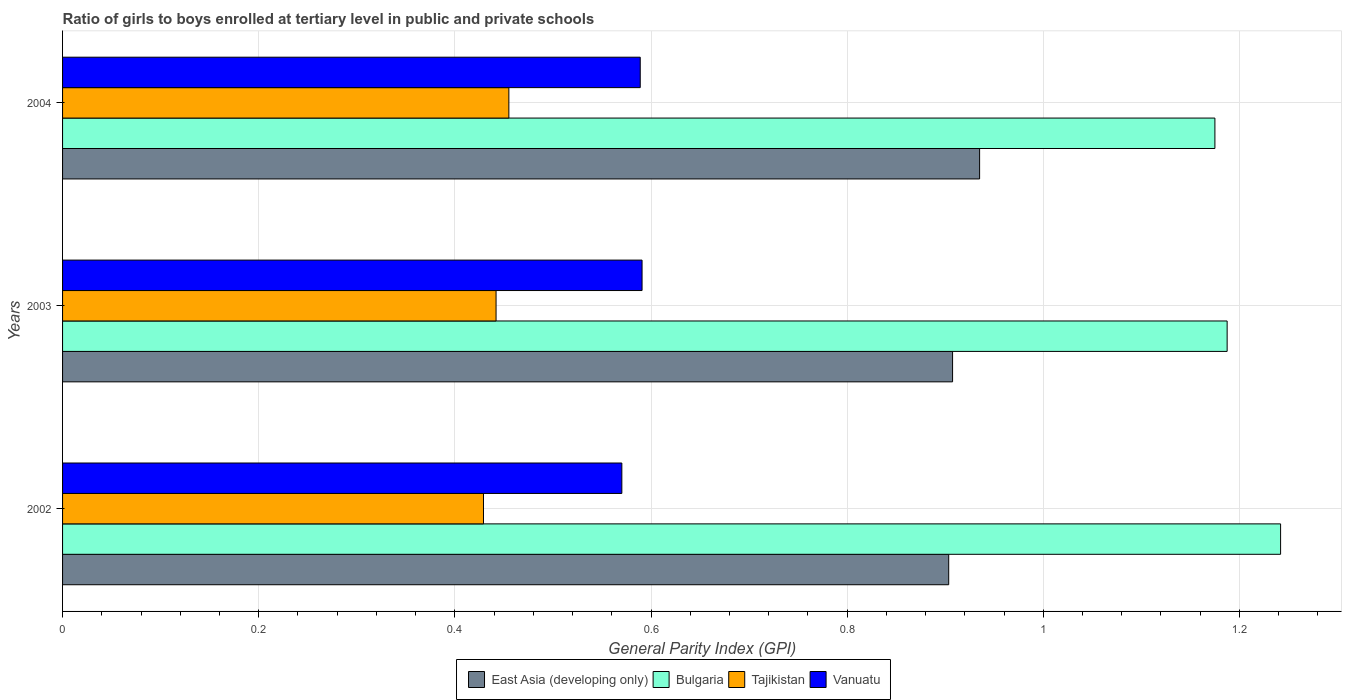How many bars are there on the 2nd tick from the top?
Keep it short and to the point. 4. In how many cases, is the number of bars for a given year not equal to the number of legend labels?
Give a very brief answer. 0. What is the general parity index in Bulgaria in 2002?
Your response must be concise. 1.24. Across all years, what is the maximum general parity index in Tajikistan?
Make the answer very short. 0.46. Across all years, what is the minimum general parity index in East Asia (developing only)?
Your answer should be very brief. 0.9. In which year was the general parity index in Vanuatu minimum?
Ensure brevity in your answer.  2002. What is the total general parity index in Bulgaria in the graph?
Provide a short and direct response. 3.6. What is the difference between the general parity index in Tajikistan in 2002 and that in 2003?
Give a very brief answer. -0.01. What is the difference between the general parity index in East Asia (developing only) in 2003 and the general parity index in Vanuatu in 2002?
Your response must be concise. 0.34. What is the average general parity index in Bulgaria per year?
Ensure brevity in your answer.  1.2. In the year 2003, what is the difference between the general parity index in Vanuatu and general parity index in Bulgaria?
Offer a very short reply. -0.6. In how many years, is the general parity index in Bulgaria greater than 1.08 ?
Offer a very short reply. 3. What is the ratio of the general parity index in Bulgaria in 2002 to that in 2004?
Your answer should be very brief. 1.06. Is the general parity index in Bulgaria in 2003 less than that in 2004?
Offer a terse response. No. What is the difference between the highest and the second highest general parity index in East Asia (developing only)?
Your response must be concise. 0.03. What is the difference between the highest and the lowest general parity index in Bulgaria?
Provide a succinct answer. 0.07. What does the 1st bar from the top in 2002 represents?
Offer a terse response. Vanuatu. What does the 1st bar from the bottom in 2003 represents?
Offer a very short reply. East Asia (developing only). Is it the case that in every year, the sum of the general parity index in Vanuatu and general parity index in Tajikistan is greater than the general parity index in Bulgaria?
Offer a very short reply. No. How many bars are there?
Make the answer very short. 12. Are all the bars in the graph horizontal?
Keep it short and to the point. Yes. Are the values on the major ticks of X-axis written in scientific E-notation?
Offer a very short reply. No. Does the graph contain any zero values?
Offer a very short reply. No. Does the graph contain grids?
Keep it short and to the point. Yes. Where does the legend appear in the graph?
Offer a terse response. Bottom center. How many legend labels are there?
Your response must be concise. 4. How are the legend labels stacked?
Offer a terse response. Horizontal. What is the title of the graph?
Your answer should be very brief. Ratio of girls to boys enrolled at tertiary level in public and private schools. What is the label or title of the X-axis?
Keep it short and to the point. General Parity Index (GPI). What is the General Parity Index (GPI) of East Asia (developing only) in 2002?
Your response must be concise. 0.9. What is the General Parity Index (GPI) of Bulgaria in 2002?
Give a very brief answer. 1.24. What is the General Parity Index (GPI) in Tajikistan in 2002?
Offer a very short reply. 0.43. What is the General Parity Index (GPI) of Vanuatu in 2002?
Your answer should be very brief. 0.57. What is the General Parity Index (GPI) in East Asia (developing only) in 2003?
Give a very brief answer. 0.91. What is the General Parity Index (GPI) in Bulgaria in 2003?
Offer a very short reply. 1.19. What is the General Parity Index (GPI) in Tajikistan in 2003?
Your answer should be very brief. 0.44. What is the General Parity Index (GPI) of Vanuatu in 2003?
Make the answer very short. 0.59. What is the General Parity Index (GPI) in East Asia (developing only) in 2004?
Your answer should be very brief. 0.94. What is the General Parity Index (GPI) of Bulgaria in 2004?
Provide a succinct answer. 1.18. What is the General Parity Index (GPI) in Tajikistan in 2004?
Offer a terse response. 0.46. What is the General Parity Index (GPI) of Vanuatu in 2004?
Your answer should be very brief. 0.59. Across all years, what is the maximum General Parity Index (GPI) of East Asia (developing only)?
Give a very brief answer. 0.94. Across all years, what is the maximum General Parity Index (GPI) of Bulgaria?
Keep it short and to the point. 1.24. Across all years, what is the maximum General Parity Index (GPI) in Tajikistan?
Ensure brevity in your answer.  0.46. Across all years, what is the maximum General Parity Index (GPI) of Vanuatu?
Keep it short and to the point. 0.59. Across all years, what is the minimum General Parity Index (GPI) of East Asia (developing only)?
Offer a terse response. 0.9. Across all years, what is the minimum General Parity Index (GPI) in Bulgaria?
Your response must be concise. 1.18. Across all years, what is the minimum General Parity Index (GPI) in Tajikistan?
Provide a short and direct response. 0.43. Across all years, what is the minimum General Parity Index (GPI) in Vanuatu?
Offer a terse response. 0.57. What is the total General Parity Index (GPI) in East Asia (developing only) in the graph?
Provide a short and direct response. 2.75. What is the total General Parity Index (GPI) of Bulgaria in the graph?
Give a very brief answer. 3.6. What is the total General Parity Index (GPI) of Tajikistan in the graph?
Your response must be concise. 1.33. What is the total General Parity Index (GPI) in Vanuatu in the graph?
Your answer should be compact. 1.75. What is the difference between the General Parity Index (GPI) in East Asia (developing only) in 2002 and that in 2003?
Your answer should be very brief. -0. What is the difference between the General Parity Index (GPI) in Bulgaria in 2002 and that in 2003?
Provide a short and direct response. 0.05. What is the difference between the General Parity Index (GPI) in Tajikistan in 2002 and that in 2003?
Your response must be concise. -0.01. What is the difference between the General Parity Index (GPI) in Vanuatu in 2002 and that in 2003?
Your answer should be compact. -0.02. What is the difference between the General Parity Index (GPI) of East Asia (developing only) in 2002 and that in 2004?
Your answer should be compact. -0.03. What is the difference between the General Parity Index (GPI) of Bulgaria in 2002 and that in 2004?
Provide a short and direct response. 0.07. What is the difference between the General Parity Index (GPI) in Tajikistan in 2002 and that in 2004?
Offer a very short reply. -0.03. What is the difference between the General Parity Index (GPI) of Vanuatu in 2002 and that in 2004?
Provide a short and direct response. -0.02. What is the difference between the General Parity Index (GPI) of East Asia (developing only) in 2003 and that in 2004?
Make the answer very short. -0.03. What is the difference between the General Parity Index (GPI) in Bulgaria in 2003 and that in 2004?
Your answer should be compact. 0.01. What is the difference between the General Parity Index (GPI) of Tajikistan in 2003 and that in 2004?
Provide a short and direct response. -0.01. What is the difference between the General Parity Index (GPI) of Vanuatu in 2003 and that in 2004?
Your answer should be very brief. 0. What is the difference between the General Parity Index (GPI) of East Asia (developing only) in 2002 and the General Parity Index (GPI) of Bulgaria in 2003?
Offer a terse response. -0.28. What is the difference between the General Parity Index (GPI) in East Asia (developing only) in 2002 and the General Parity Index (GPI) in Tajikistan in 2003?
Give a very brief answer. 0.46. What is the difference between the General Parity Index (GPI) of East Asia (developing only) in 2002 and the General Parity Index (GPI) of Vanuatu in 2003?
Offer a terse response. 0.31. What is the difference between the General Parity Index (GPI) in Bulgaria in 2002 and the General Parity Index (GPI) in Tajikistan in 2003?
Offer a terse response. 0.8. What is the difference between the General Parity Index (GPI) of Bulgaria in 2002 and the General Parity Index (GPI) of Vanuatu in 2003?
Ensure brevity in your answer.  0.65. What is the difference between the General Parity Index (GPI) of Tajikistan in 2002 and the General Parity Index (GPI) of Vanuatu in 2003?
Offer a very short reply. -0.16. What is the difference between the General Parity Index (GPI) of East Asia (developing only) in 2002 and the General Parity Index (GPI) of Bulgaria in 2004?
Your response must be concise. -0.27. What is the difference between the General Parity Index (GPI) of East Asia (developing only) in 2002 and the General Parity Index (GPI) of Tajikistan in 2004?
Your answer should be compact. 0.45. What is the difference between the General Parity Index (GPI) in East Asia (developing only) in 2002 and the General Parity Index (GPI) in Vanuatu in 2004?
Provide a short and direct response. 0.31. What is the difference between the General Parity Index (GPI) of Bulgaria in 2002 and the General Parity Index (GPI) of Tajikistan in 2004?
Your answer should be compact. 0.79. What is the difference between the General Parity Index (GPI) of Bulgaria in 2002 and the General Parity Index (GPI) of Vanuatu in 2004?
Your response must be concise. 0.65. What is the difference between the General Parity Index (GPI) in Tajikistan in 2002 and the General Parity Index (GPI) in Vanuatu in 2004?
Provide a succinct answer. -0.16. What is the difference between the General Parity Index (GPI) of East Asia (developing only) in 2003 and the General Parity Index (GPI) of Bulgaria in 2004?
Offer a terse response. -0.27. What is the difference between the General Parity Index (GPI) of East Asia (developing only) in 2003 and the General Parity Index (GPI) of Tajikistan in 2004?
Make the answer very short. 0.45. What is the difference between the General Parity Index (GPI) of East Asia (developing only) in 2003 and the General Parity Index (GPI) of Vanuatu in 2004?
Ensure brevity in your answer.  0.32. What is the difference between the General Parity Index (GPI) of Bulgaria in 2003 and the General Parity Index (GPI) of Tajikistan in 2004?
Provide a succinct answer. 0.73. What is the difference between the General Parity Index (GPI) in Bulgaria in 2003 and the General Parity Index (GPI) in Vanuatu in 2004?
Provide a short and direct response. 0.6. What is the difference between the General Parity Index (GPI) in Tajikistan in 2003 and the General Parity Index (GPI) in Vanuatu in 2004?
Ensure brevity in your answer.  -0.15. What is the average General Parity Index (GPI) in East Asia (developing only) per year?
Make the answer very short. 0.92. What is the average General Parity Index (GPI) in Bulgaria per year?
Give a very brief answer. 1.2. What is the average General Parity Index (GPI) in Tajikistan per year?
Your answer should be very brief. 0.44. What is the average General Parity Index (GPI) of Vanuatu per year?
Offer a very short reply. 0.58. In the year 2002, what is the difference between the General Parity Index (GPI) in East Asia (developing only) and General Parity Index (GPI) in Bulgaria?
Offer a very short reply. -0.34. In the year 2002, what is the difference between the General Parity Index (GPI) in East Asia (developing only) and General Parity Index (GPI) in Tajikistan?
Your answer should be very brief. 0.47. In the year 2002, what is the difference between the General Parity Index (GPI) in Bulgaria and General Parity Index (GPI) in Tajikistan?
Ensure brevity in your answer.  0.81. In the year 2002, what is the difference between the General Parity Index (GPI) in Bulgaria and General Parity Index (GPI) in Vanuatu?
Your answer should be very brief. 0.67. In the year 2002, what is the difference between the General Parity Index (GPI) in Tajikistan and General Parity Index (GPI) in Vanuatu?
Make the answer very short. -0.14. In the year 2003, what is the difference between the General Parity Index (GPI) of East Asia (developing only) and General Parity Index (GPI) of Bulgaria?
Provide a succinct answer. -0.28. In the year 2003, what is the difference between the General Parity Index (GPI) in East Asia (developing only) and General Parity Index (GPI) in Tajikistan?
Provide a succinct answer. 0.47. In the year 2003, what is the difference between the General Parity Index (GPI) of East Asia (developing only) and General Parity Index (GPI) of Vanuatu?
Offer a terse response. 0.32. In the year 2003, what is the difference between the General Parity Index (GPI) in Bulgaria and General Parity Index (GPI) in Tajikistan?
Ensure brevity in your answer.  0.75. In the year 2003, what is the difference between the General Parity Index (GPI) in Bulgaria and General Parity Index (GPI) in Vanuatu?
Give a very brief answer. 0.6. In the year 2003, what is the difference between the General Parity Index (GPI) in Tajikistan and General Parity Index (GPI) in Vanuatu?
Make the answer very short. -0.15. In the year 2004, what is the difference between the General Parity Index (GPI) of East Asia (developing only) and General Parity Index (GPI) of Bulgaria?
Offer a very short reply. -0.24. In the year 2004, what is the difference between the General Parity Index (GPI) in East Asia (developing only) and General Parity Index (GPI) in Tajikistan?
Your answer should be very brief. 0.48. In the year 2004, what is the difference between the General Parity Index (GPI) of East Asia (developing only) and General Parity Index (GPI) of Vanuatu?
Keep it short and to the point. 0.35. In the year 2004, what is the difference between the General Parity Index (GPI) of Bulgaria and General Parity Index (GPI) of Tajikistan?
Your response must be concise. 0.72. In the year 2004, what is the difference between the General Parity Index (GPI) in Bulgaria and General Parity Index (GPI) in Vanuatu?
Provide a short and direct response. 0.59. In the year 2004, what is the difference between the General Parity Index (GPI) of Tajikistan and General Parity Index (GPI) of Vanuatu?
Ensure brevity in your answer.  -0.13. What is the ratio of the General Parity Index (GPI) in East Asia (developing only) in 2002 to that in 2003?
Your answer should be very brief. 1. What is the ratio of the General Parity Index (GPI) of Bulgaria in 2002 to that in 2003?
Offer a very short reply. 1.05. What is the ratio of the General Parity Index (GPI) of Tajikistan in 2002 to that in 2003?
Provide a succinct answer. 0.97. What is the ratio of the General Parity Index (GPI) in Vanuatu in 2002 to that in 2003?
Provide a succinct answer. 0.97. What is the ratio of the General Parity Index (GPI) in East Asia (developing only) in 2002 to that in 2004?
Offer a terse response. 0.97. What is the ratio of the General Parity Index (GPI) of Bulgaria in 2002 to that in 2004?
Your answer should be very brief. 1.06. What is the ratio of the General Parity Index (GPI) in Tajikistan in 2002 to that in 2004?
Provide a short and direct response. 0.94. What is the ratio of the General Parity Index (GPI) in Vanuatu in 2002 to that in 2004?
Offer a terse response. 0.97. What is the ratio of the General Parity Index (GPI) of East Asia (developing only) in 2003 to that in 2004?
Give a very brief answer. 0.97. What is the ratio of the General Parity Index (GPI) of Bulgaria in 2003 to that in 2004?
Your answer should be very brief. 1.01. What is the ratio of the General Parity Index (GPI) in Tajikistan in 2003 to that in 2004?
Offer a terse response. 0.97. What is the ratio of the General Parity Index (GPI) of Vanuatu in 2003 to that in 2004?
Offer a terse response. 1. What is the difference between the highest and the second highest General Parity Index (GPI) of East Asia (developing only)?
Offer a very short reply. 0.03. What is the difference between the highest and the second highest General Parity Index (GPI) in Bulgaria?
Offer a very short reply. 0.05. What is the difference between the highest and the second highest General Parity Index (GPI) of Tajikistan?
Keep it short and to the point. 0.01. What is the difference between the highest and the second highest General Parity Index (GPI) of Vanuatu?
Your answer should be compact. 0. What is the difference between the highest and the lowest General Parity Index (GPI) of East Asia (developing only)?
Provide a succinct answer. 0.03. What is the difference between the highest and the lowest General Parity Index (GPI) in Bulgaria?
Give a very brief answer. 0.07. What is the difference between the highest and the lowest General Parity Index (GPI) in Tajikistan?
Make the answer very short. 0.03. What is the difference between the highest and the lowest General Parity Index (GPI) in Vanuatu?
Offer a very short reply. 0.02. 